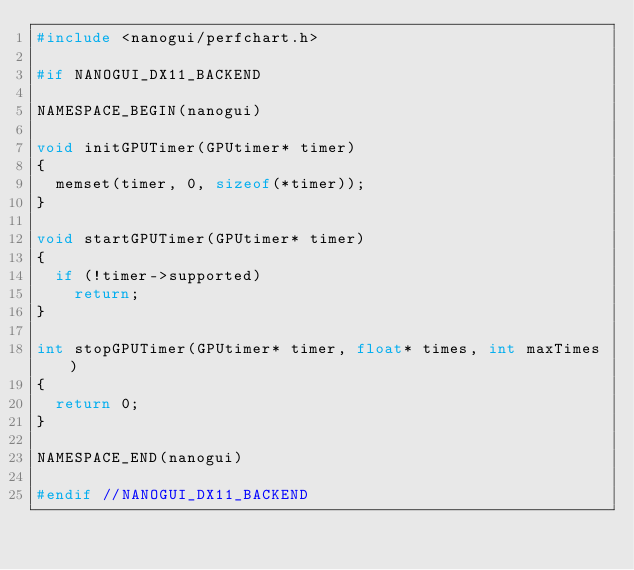Convert code to text. <code><loc_0><loc_0><loc_500><loc_500><_C++_>#include <nanogui/perfchart.h>

#if NANOGUI_DX11_BACKEND

NAMESPACE_BEGIN(nanogui)

void initGPUTimer(GPUtimer* timer)
{
  memset(timer, 0, sizeof(*timer));
}

void startGPUTimer(GPUtimer* timer)
{
  if (!timer->supported)
    return;
}

int stopGPUTimer(GPUtimer* timer, float* times, int maxTimes)
{
  return 0;
}

NAMESPACE_END(nanogui)

#endif //NANOGUI_DX11_BACKEND</code> 